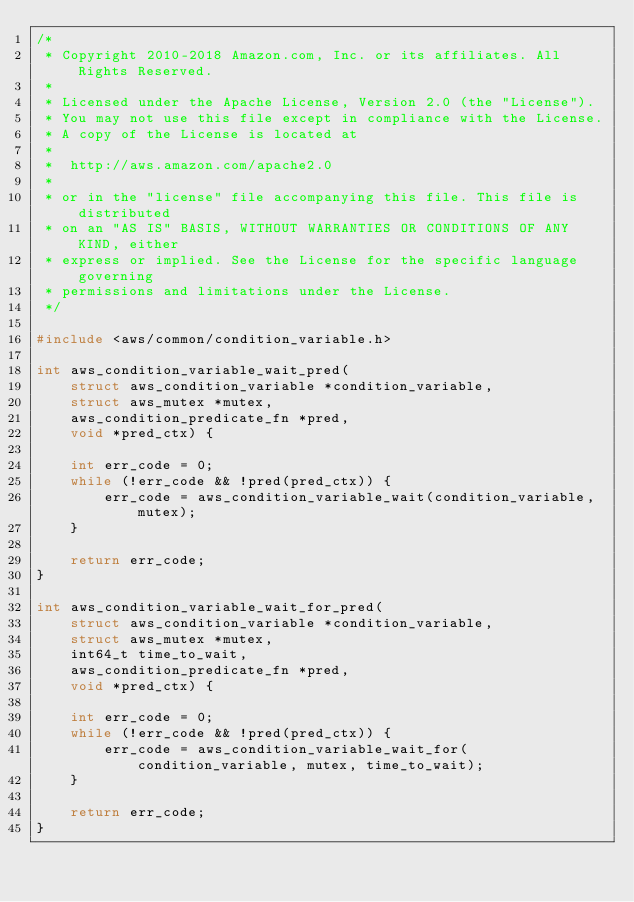Convert code to text. <code><loc_0><loc_0><loc_500><loc_500><_C_>/*
 * Copyright 2010-2018 Amazon.com, Inc. or its affiliates. All Rights Reserved.
 *
 * Licensed under the Apache License, Version 2.0 (the "License").
 * You may not use this file except in compliance with the License.
 * A copy of the License is located at
 *
 *  http://aws.amazon.com/apache2.0
 *
 * or in the "license" file accompanying this file. This file is distributed
 * on an "AS IS" BASIS, WITHOUT WARRANTIES OR CONDITIONS OF ANY KIND, either
 * express or implied. See the License for the specific language governing
 * permissions and limitations under the License.
 */

#include <aws/common/condition_variable.h>

int aws_condition_variable_wait_pred(
    struct aws_condition_variable *condition_variable,
    struct aws_mutex *mutex,
    aws_condition_predicate_fn *pred,
    void *pred_ctx) {

    int err_code = 0;
    while (!err_code && !pred(pred_ctx)) {
        err_code = aws_condition_variable_wait(condition_variable, mutex);
    }

    return err_code;
}

int aws_condition_variable_wait_for_pred(
    struct aws_condition_variable *condition_variable,
    struct aws_mutex *mutex,
    int64_t time_to_wait,
    aws_condition_predicate_fn *pred,
    void *pred_ctx) {

    int err_code = 0;
    while (!err_code && !pred(pred_ctx)) {
        err_code = aws_condition_variable_wait_for(condition_variable, mutex, time_to_wait);
    }

    return err_code;
}
</code> 